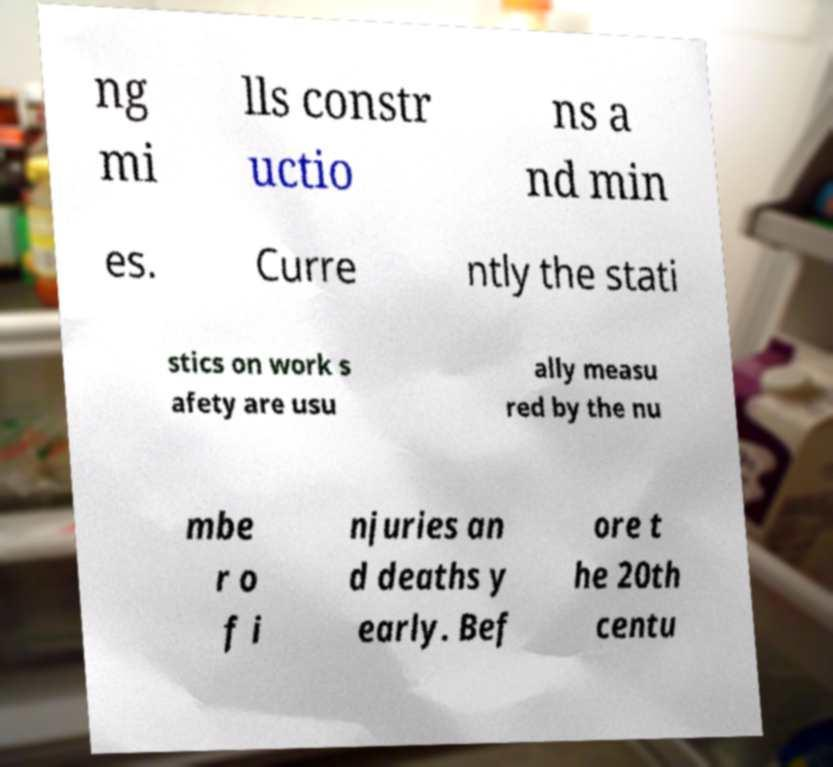Could you extract and type out the text from this image? ng mi lls constr uctio ns a nd min es. Curre ntly the stati stics on work s afety are usu ally measu red by the nu mbe r o f i njuries an d deaths y early. Bef ore t he 20th centu 